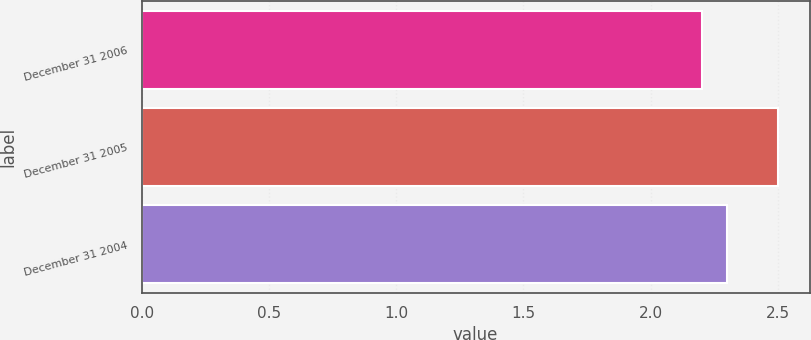<chart> <loc_0><loc_0><loc_500><loc_500><bar_chart><fcel>December 31 2006<fcel>December 31 2005<fcel>December 31 2004<nl><fcel>2.2<fcel>2.5<fcel>2.3<nl></chart> 